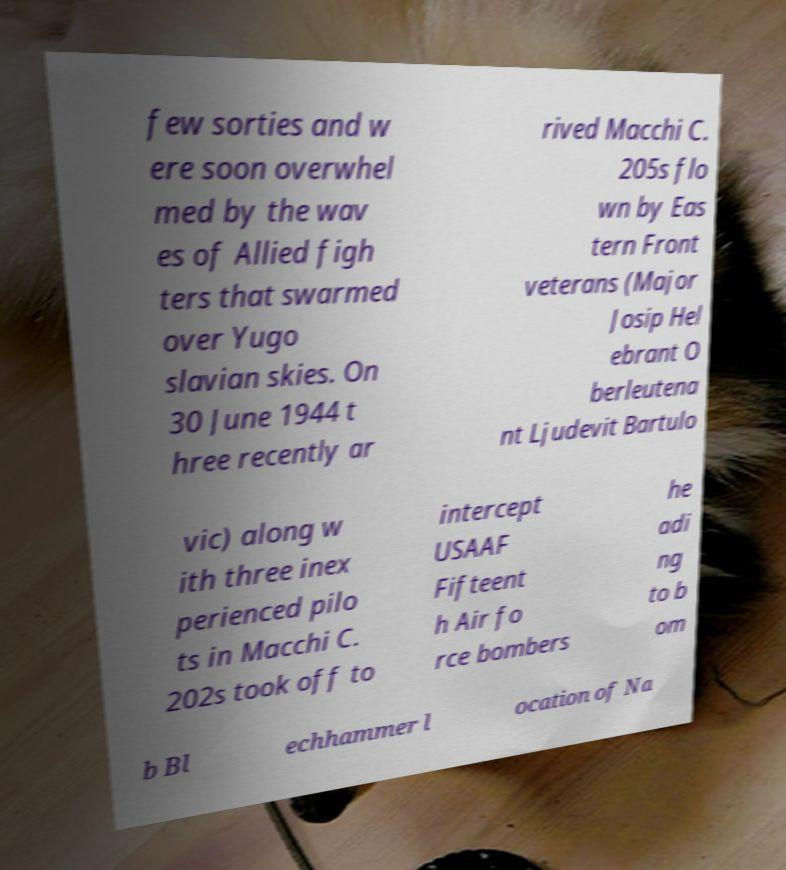There's text embedded in this image that I need extracted. Can you transcribe it verbatim? few sorties and w ere soon overwhel med by the wav es of Allied figh ters that swarmed over Yugo slavian skies. On 30 June 1944 t hree recently ar rived Macchi C. 205s flo wn by Eas tern Front veterans (Major Josip Hel ebrant O berleutena nt Ljudevit Bartulo vic) along w ith three inex perienced pilo ts in Macchi C. 202s took off to intercept USAAF Fifteent h Air fo rce bombers he adi ng to b om b Bl echhammer l ocation of Na 